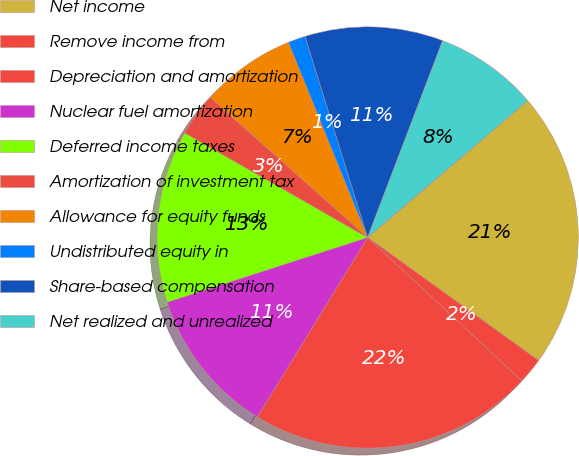Convert chart to OTSL. <chart><loc_0><loc_0><loc_500><loc_500><pie_chart><fcel>Net income<fcel>Remove income from<fcel>Depreciation and amortization<fcel>Nuclear fuel amortization<fcel>Deferred income taxes<fcel>Amortization of investment tax<fcel>Allowance for equity funds<fcel>Undistributed equity in<fcel>Share-based compensation<fcel>Net realized and unrealized<nl><fcel>21.19%<fcel>1.99%<fcel>21.85%<fcel>11.26%<fcel>13.24%<fcel>3.31%<fcel>7.29%<fcel>1.33%<fcel>10.6%<fcel>7.95%<nl></chart> 